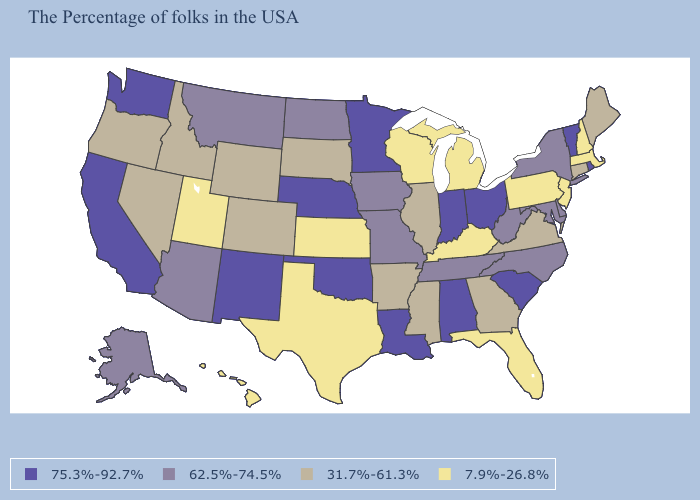Name the states that have a value in the range 75.3%-92.7%?
Write a very short answer. Rhode Island, Vermont, South Carolina, Ohio, Indiana, Alabama, Louisiana, Minnesota, Nebraska, Oklahoma, New Mexico, California, Washington. What is the highest value in the Northeast ?
Answer briefly. 75.3%-92.7%. What is the value of South Dakota?
Concise answer only. 31.7%-61.3%. What is the value of Vermont?
Answer briefly. 75.3%-92.7%. What is the value of California?
Quick response, please. 75.3%-92.7%. What is the value of New Hampshire?
Concise answer only. 7.9%-26.8%. What is the value of New Mexico?
Keep it brief. 75.3%-92.7%. What is the highest value in the MidWest ?
Give a very brief answer. 75.3%-92.7%. What is the value of Maryland?
Short answer required. 62.5%-74.5%. Name the states that have a value in the range 75.3%-92.7%?
Keep it brief. Rhode Island, Vermont, South Carolina, Ohio, Indiana, Alabama, Louisiana, Minnesota, Nebraska, Oklahoma, New Mexico, California, Washington. Name the states that have a value in the range 62.5%-74.5%?
Answer briefly. New York, Delaware, Maryland, North Carolina, West Virginia, Tennessee, Missouri, Iowa, North Dakota, Montana, Arizona, Alaska. Name the states that have a value in the range 31.7%-61.3%?
Keep it brief. Maine, Connecticut, Virginia, Georgia, Illinois, Mississippi, Arkansas, South Dakota, Wyoming, Colorado, Idaho, Nevada, Oregon. What is the highest value in the USA?
Write a very short answer. 75.3%-92.7%. What is the value of Oregon?
Be succinct. 31.7%-61.3%. What is the value of Illinois?
Be succinct. 31.7%-61.3%. 